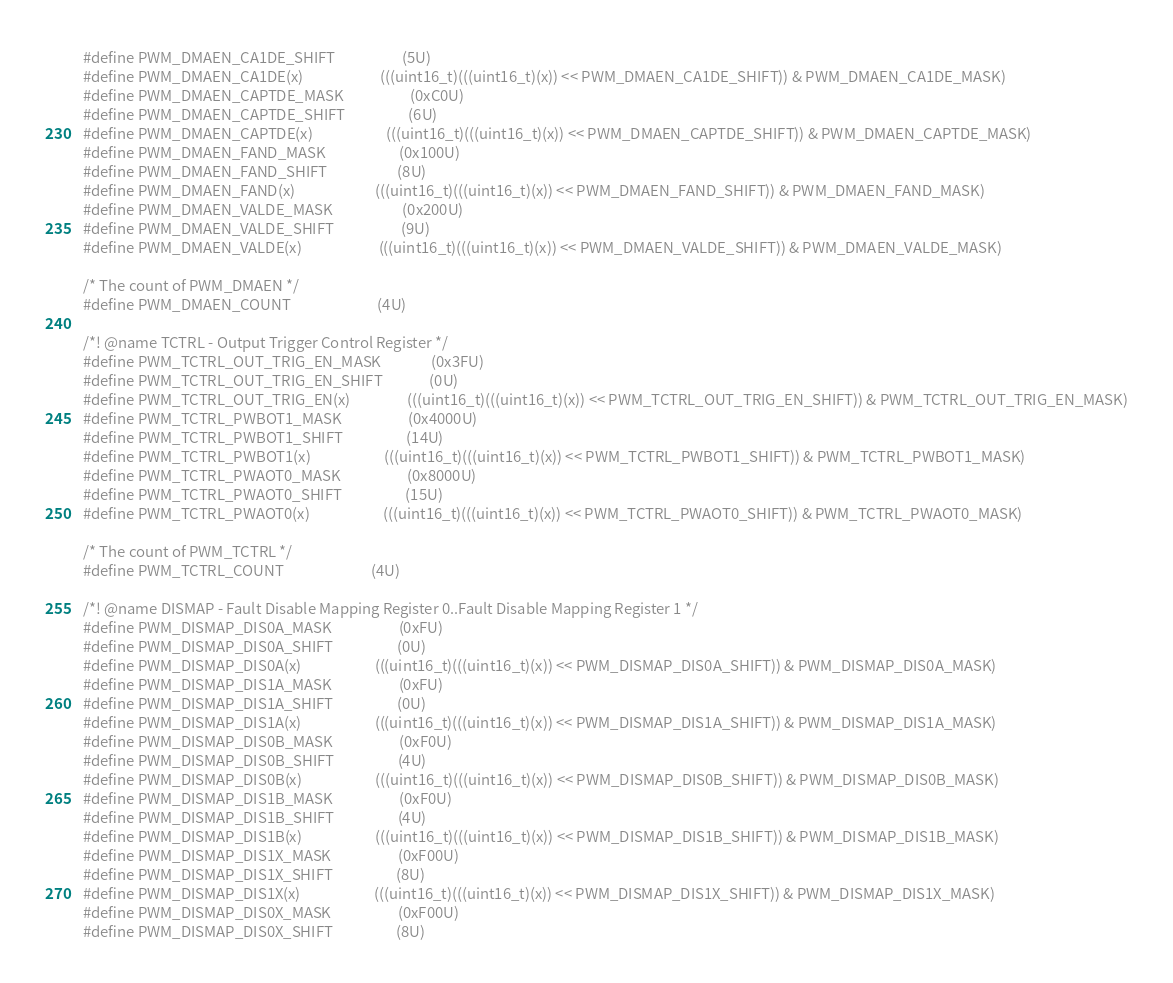Convert code to text. <code><loc_0><loc_0><loc_500><loc_500><_C_>#define PWM_DMAEN_CA1DE_SHIFT                    (5U)
#define PWM_DMAEN_CA1DE(x)                       (((uint16_t)(((uint16_t)(x)) << PWM_DMAEN_CA1DE_SHIFT)) & PWM_DMAEN_CA1DE_MASK)
#define PWM_DMAEN_CAPTDE_MASK                    (0xC0U)
#define PWM_DMAEN_CAPTDE_SHIFT                   (6U)
#define PWM_DMAEN_CAPTDE(x)                      (((uint16_t)(((uint16_t)(x)) << PWM_DMAEN_CAPTDE_SHIFT)) & PWM_DMAEN_CAPTDE_MASK)
#define PWM_DMAEN_FAND_MASK                      (0x100U)
#define PWM_DMAEN_FAND_SHIFT                     (8U)
#define PWM_DMAEN_FAND(x)                        (((uint16_t)(((uint16_t)(x)) << PWM_DMAEN_FAND_SHIFT)) & PWM_DMAEN_FAND_MASK)
#define PWM_DMAEN_VALDE_MASK                     (0x200U)
#define PWM_DMAEN_VALDE_SHIFT                    (9U)
#define PWM_DMAEN_VALDE(x)                       (((uint16_t)(((uint16_t)(x)) << PWM_DMAEN_VALDE_SHIFT)) & PWM_DMAEN_VALDE_MASK)

/* The count of PWM_DMAEN */
#define PWM_DMAEN_COUNT                          (4U)

/*! @name TCTRL - Output Trigger Control Register */
#define PWM_TCTRL_OUT_TRIG_EN_MASK               (0x3FU)
#define PWM_TCTRL_OUT_TRIG_EN_SHIFT              (0U)
#define PWM_TCTRL_OUT_TRIG_EN(x)                 (((uint16_t)(((uint16_t)(x)) << PWM_TCTRL_OUT_TRIG_EN_SHIFT)) & PWM_TCTRL_OUT_TRIG_EN_MASK)
#define PWM_TCTRL_PWBOT1_MASK                    (0x4000U)
#define PWM_TCTRL_PWBOT1_SHIFT                   (14U)
#define PWM_TCTRL_PWBOT1(x)                      (((uint16_t)(((uint16_t)(x)) << PWM_TCTRL_PWBOT1_SHIFT)) & PWM_TCTRL_PWBOT1_MASK)
#define PWM_TCTRL_PWAOT0_MASK                    (0x8000U)
#define PWM_TCTRL_PWAOT0_SHIFT                   (15U)
#define PWM_TCTRL_PWAOT0(x)                      (((uint16_t)(((uint16_t)(x)) << PWM_TCTRL_PWAOT0_SHIFT)) & PWM_TCTRL_PWAOT0_MASK)

/* The count of PWM_TCTRL */
#define PWM_TCTRL_COUNT                          (4U)

/*! @name DISMAP - Fault Disable Mapping Register 0..Fault Disable Mapping Register 1 */
#define PWM_DISMAP_DIS0A_MASK                    (0xFU)
#define PWM_DISMAP_DIS0A_SHIFT                   (0U)
#define PWM_DISMAP_DIS0A(x)                      (((uint16_t)(((uint16_t)(x)) << PWM_DISMAP_DIS0A_SHIFT)) & PWM_DISMAP_DIS0A_MASK)
#define PWM_DISMAP_DIS1A_MASK                    (0xFU)
#define PWM_DISMAP_DIS1A_SHIFT                   (0U)
#define PWM_DISMAP_DIS1A(x)                      (((uint16_t)(((uint16_t)(x)) << PWM_DISMAP_DIS1A_SHIFT)) & PWM_DISMAP_DIS1A_MASK)
#define PWM_DISMAP_DIS0B_MASK                    (0xF0U)
#define PWM_DISMAP_DIS0B_SHIFT                   (4U)
#define PWM_DISMAP_DIS0B(x)                      (((uint16_t)(((uint16_t)(x)) << PWM_DISMAP_DIS0B_SHIFT)) & PWM_DISMAP_DIS0B_MASK)
#define PWM_DISMAP_DIS1B_MASK                    (0xF0U)
#define PWM_DISMAP_DIS1B_SHIFT                   (4U)
#define PWM_DISMAP_DIS1B(x)                      (((uint16_t)(((uint16_t)(x)) << PWM_DISMAP_DIS1B_SHIFT)) & PWM_DISMAP_DIS1B_MASK)
#define PWM_DISMAP_DIS1X_MASK                    (0xF00U)
#define PWM_DISMAP_DIS1X_SHIFT                   (8U)
#define PWM_DISMAP_DIS1X(x)                      (((uint16_t)(((uint16_t)(x)) << PWM_DISMAP_DIS1X_SHIFT)) & PWM_DISMAP_DIS1X_MASK)
#define PWM_DISMAP_DIS0X_MASK                    (0xF00U)
#define PWM_DISMAP_DIS0X_SHIFT                   (8U)</code> 